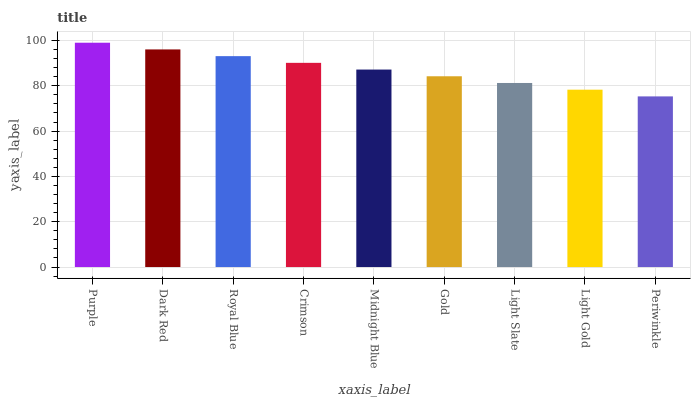Is Periwinkle the minimum?
Answer yes or no. Yes. Is Purple the maximum?
Answer yes or no. Yes. Is Dark Red the minimum?
Answer yes or no. No. Is Dark Red the maximum?
Answer yes or no. No. Is Purple greater than Dark Red?
Answer yes or no. Yes. Is Dark Red less than Purple?
Answer yes or no. Yes. Is Dark Red greater than Purple?
Answer yes or no. No. Is Purple less than Dark Red?
Answer yes or no. No. Is Midnight Blue the high median?
Answer yes or no. Yes. Is Midnight Blue the low median?
Answer yes or no. Yes. Is Light Gold the high median?
Answer yes or no. No. Is Gold the low median?
Answer yes or no. No. 